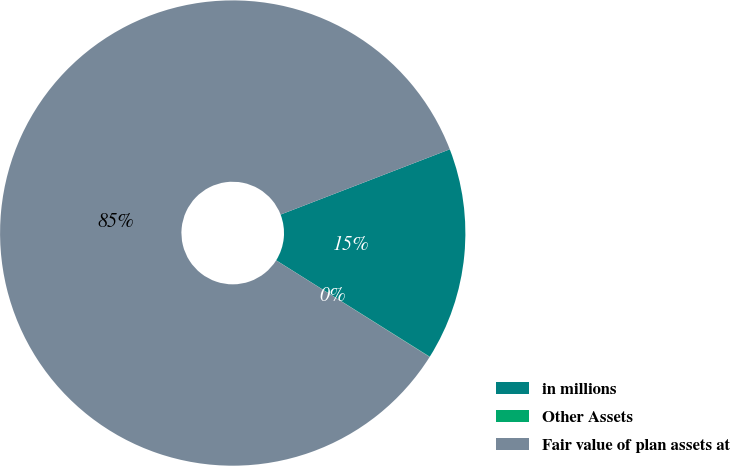Convert chart. <chart><loc_0><loc_0><loc_500><loc_500><pie_chart><fcel>in millions<fcel>Other Assets<fcel>Fair value of plan assets at<nl><fcel>14.78%<fcel>0.02%<fcel>85.2%<nl></chart> 